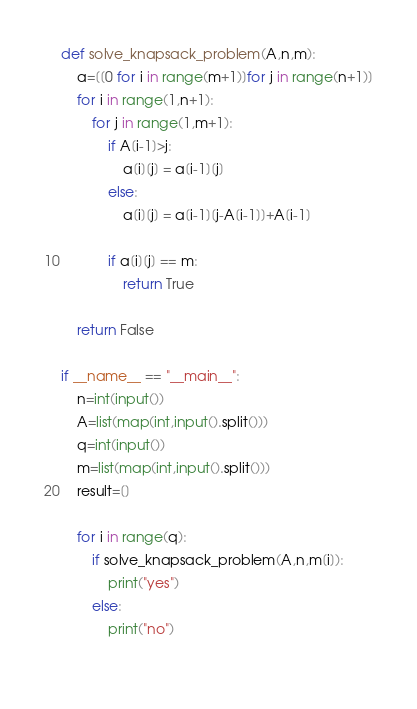<code> <loc_0><loc_0><loc_500><loc_500><_Python_>def solve_knapsack_problem(A,n,m):
    a=[[0 for i in range(m+1)]for j in range(n+1)]
    for i in range(1,n+1):
        for j in range(1,m+1):
            if A[i-1]>j:
                a[i][j] = a[i-1][j]
            else:
                a[i][j] = a[i-1][j-A[i-1]]+A[i-1]
            
            if a[i][j] == m:
                return True

    return False

if __name__ == "__main__":
    n=int(input())
    A=list(map(int,input().split()))
    q=int(input())
    m=list(map(int,input().split()))
    result=[]

    for i in range(q):
        if solve_knapsack_problem(A,n,m[i]):
            print("yes")
        else:
            print("no")
                    
</code> 